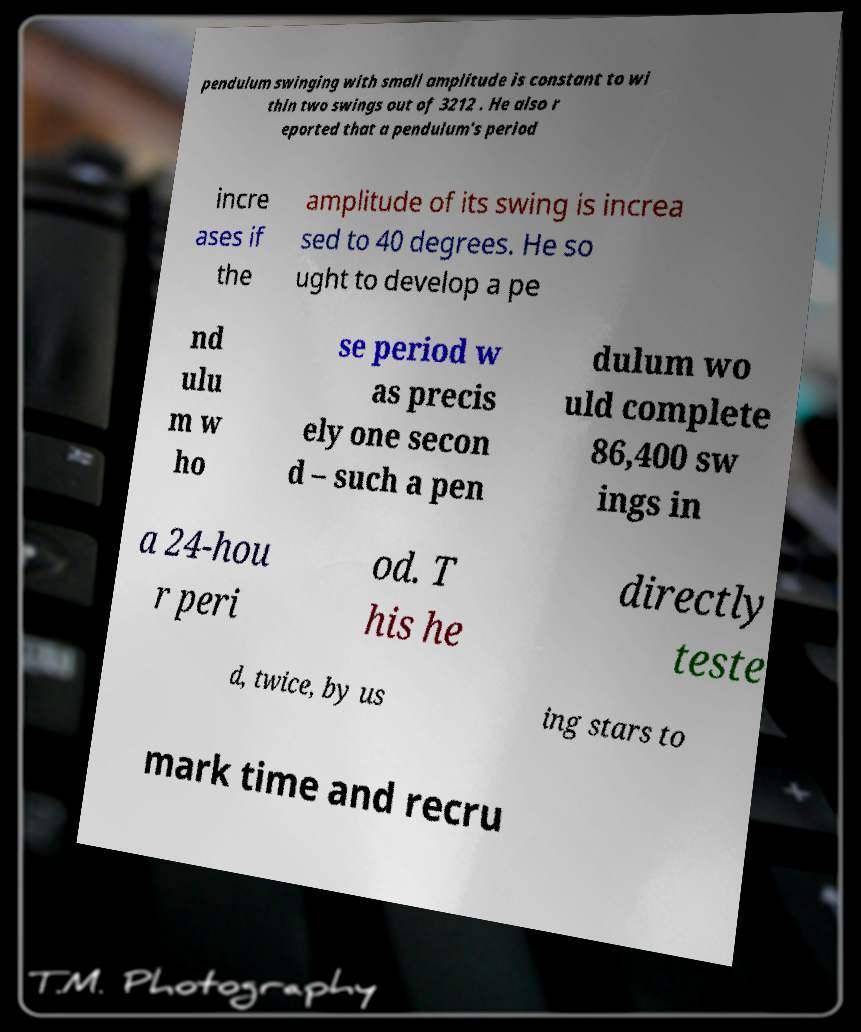What messages or text are displayed in this image? I need them in a readable, typed format. pendulum swinging with small amplitude is constant to wi thin two swings out of 3212 . He also r eported that a pendulum's period incre ases if the amplitude of its swing is increa sed to 40 degrees. He so ught to develop a pe nd ulu m w ho se period w as precis ely one secon d – such a pen dulum wo uld complete 86,400 sw ings in a 24-hou r peri od. T his he directly teste d, twice, by us ing stars to mark time and recru 